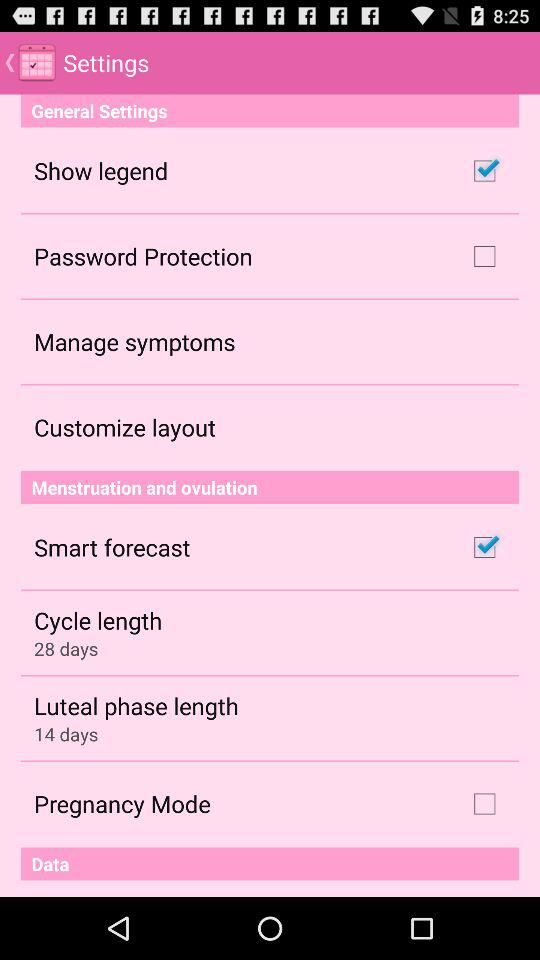What is the status of "Password Protection"? The status of "Password Protection" is "off". 